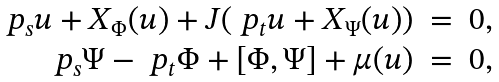<formula> <loc_0><loc_0><loc_500><loc_500>\begin{array} { r c l } \ p _ { s } u + X _ { \Phi } ( u ) + J ( \ p _ { t } u + X _ { \Psi } ( u ) ) & = & 0 , \\ \ p _ { s } \Psi - \ p _ { t } \Phi + [ \Phi , \Psi ] + \mu ( u ) & = & 0 , \end{array}</formula> 